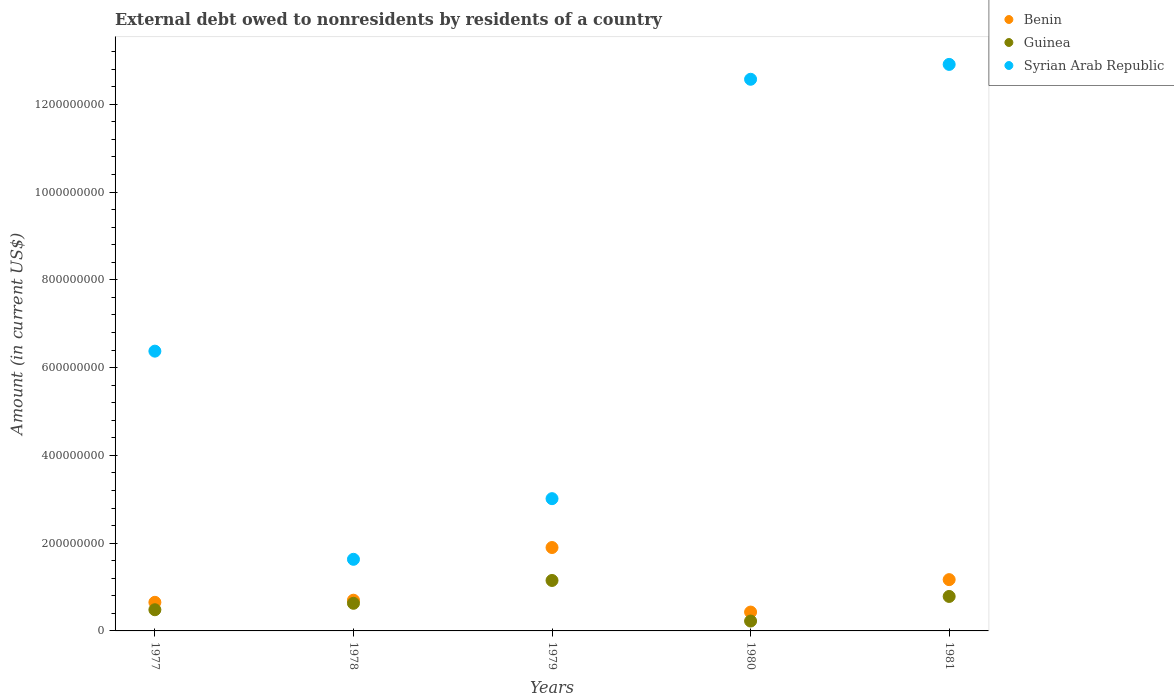How many different coloured dotlines are there?
Keep it short and to the point. 3. What is the external debt owed by residents in Benin in 1981?
Keep it short and to the point. 1.17e+08. Across all years, what is the maximum external debt owed by residents in Guinea?
Make the answer very short. 1.15e+08. Across all years, what is the minimum external debt owed by residents in Benin?
Provide a short and direct response. 4.30e+07. In which year was the external debt owed by residents in Syrian Arab Republic maximum?
Provide a short and direct response. 1981. What is the total external debt owed by residents in Guinea in the graph?
Make the answer very short. 3.27e+08. What is the difference between the external debt owed by residents in Benin in 1977 and that in 1978?
Offer a terse response. -4.82e+06. What is the difference between the external debt owed by residents in Benin in 1981 and the external debt owed by residents in Guinea in 1977?
Your response must be concise. 6.86e+07. What is the average external debt owed by residents in Benin per year?
Offer a terse response. 9.70e+07. In the year 1980, what is the difference between the external debt owed by residents in Guinea and external debt owed by residents in Syrian Arab Republic?
Your response must be concise. -1.23e+09. What is the ratio of the external debt owed by residents in Guinea in 1977 to that in 1978?
Offer a very short reply. 0.77. Is the difference between the external debt owed by residents in Guinea in 1978 and 1979 greater than the difference between the external debt owed by residents in Syrian Arab Republic in 1978 and 1979?
Offer a very short reply. Yes. What is the difference between the highest and the second highest external debt owed by residents in Guinea?
Your answer should be very brief. 3.64e+07. What is the difference between the highest and the lowest external debt owed by residents in Benin?
Provide a short and direct response. 1.47e+08. In how many years, is the external debt owed by residents in Benin greater than the average external debt owed by residents in Benin taken over all years?
Your response must be concise. 2. Does the external debt owed by residents in Syrian Arab Republic monotonically increase over the years?
Your answer should be very brief. No. Is the external debt owed by residents in Benin strictly less than the external debt owed by residents in Syrian Arab Republic over the years?
Offer a very short reply. Yes. How many dotlines are there?
Give a very brief answer. 3. How many years are there in the graph?
Give a very brief answer. 5. Does the graph contain any zero values?
Offer a terse response. No. How many legend labels are there?
Provide a short and direct response. 3. How are the legend labels stacked?
Ensure brevity in your answer.  Vertical. What is the title of the graph?
Ensure brevity in your answer.  External debt owed to nonresidents by residents of a country. What is the Amount (in current US$) of Benin in 1977?
Make the answer very short. 6.52e+07. What is the Amount (in current US$) in Guinea in 1977?
Provide a short and direct response. 4.82e+07. What is the Amount (in current US$) of Syrian Arab Republic in 1977?
Offer a very short reply. 6.37e+08. What is the Amount (in current US$) in Benin in 1978?
Your answer should be very brief. 7.00e+07. What is the Amount (in current US$) in Guinea in 1978?
Keep it short and to the point. 6.29e+07. What is the Amount (in current US$) of Syrian Arab Republic in 1978?
Ensure brevity in your answer.  1.63e+08. What is the Amount (in current US$) of Benin in 1979?
Your response must be concise. 1.90e+08. What is the Amount (in current US$) in Guinea in 1979?
Your answer should be compact. 1.15e+08. What is the Amount (in current US$) of Syrian Arab Republic in 1979?
Your answer should be very brief. 3.01e+08. What is the Amount (in current US$) of Benin in 1980?
Provide a short and direct response. 4.30e+07. What is the Amount (in current US$) in Guinea in 1980?
Offer a very short reply. 2.25e+07. What is the Amount (in current US$) in Syrian Arab Republic in 1980?
Offer a very short reply. 1.26e+09. What is the Amount (in current US$) of Benin in 1981?
Keep it short and to the point. 1.17e+08. What is the Amount (in current US$) in Guinea in 1981?
Your response must be concise. 7.85e+07. What is the Amount (in current US$) of Syrian Arab Republic in 1981?
Ensure brevity in your answer.  1.29e+09. Across all years, what is the maximum Amount (in current US$) of Benin?
Provide a succinct answer. 1.90e+08. Across all years, what is the maximum Amount (in current US$) in Guinea?
Provide a short and direct response. 1.15e+08. Across all years, what is the maximum Amount (in current US$) of Syrian Arab Republic?
Make the answer very short. 1.29e+09. Across all years, what is the minimum Amount (in current US$) in Benin?
Keep it short and to the point. 4.30e+07. Across all years, what is the minimum Amount (in current US$) in Guinea?
Give a very brief answer. 2.25e+07. Across all years, what is the minimum Amount (in current US$) in Syrian Arab Republic?
Your response must be concise. 1.63e+08. What is the total Amount (in current US$) in Benin in the graph?
Offer a terse response. 4.85e+08. What is the total Amount (in current US$) of Guinea in the graph?
Your response must be concise. 3.27e+08. What is the total Amount (in current US$) in Syrian Arab Republic in the graph?
Ensure brevity in your answer.  3.65e+09. What is the difference between the Amount (in current US$) of Benin in 1977 and that in 1978?
Give a very brief answer. -4.82e+06. What is the difference between the Amount (in current US$) in Guinea in 1977 and that in 1978?
Provide a succinct answer. -1.47e+07. What is the difference between the Amount (in current US$) in Syrian Arab Republic in 1977 and that in 1978?
Provide a short and direct response. 4.74e+08. What is the difference between the Amount (in current US$) of Benin in 1977 and that in 1979?
Your answer should be compact. -1.25e+08. What is the difference between the Amount (in current US$) in Guinea in 1977 and that in 1979?
Offer a very short reply. -6.67e+07. What is the difference between the Amount (in current US$) of Syrian Arab Republic in 1977 and that in 1979?
Offer a very short reply. 3.36e+08. What is the difference between the Amount (in current US$) of Benin in 1977 and that in 1980?
Your answer should be compact. 2.22e+07. What is the difference between the Amount (in current US$) in Guinea in 1977 and that in 1980?
Give a very brief answer. 2.58e+07. What is the difference between the Amount (in current US$) in Syrian Arab Republic in 1977 and that in 1980?
Ensure brevity in your answer.  -6.19e+08. What is the difference between the Amount (in current US$) in Benin in 1977 and that in 1981?
Your answer should be compact. -5.17e+07. What is the difference between the Amount (in current US$) in Guinea in 1977 and that in 1981?
Provide a succinct answer. -3.03e+07. What is the difference between the Amount (in current US$) in Syrian Arab Republic in 1977 and that in 1981?
Offer a terse response. -6.53e+08. What is the difference between the Amount (in current US$) in Benin in 1978 and that in 1979?
Provide a succinct answer. -1.20e+08. What is the difference between the Amount (in current US$) in Guinea in 1978 and that in 1979?
Your answer should be very brief. -5.20e+07. What is the difference between the Amount (in current US$) of Syrian Arab Republic in 1978 and that in 1979?
Your response must be concise. -1.38e+08. What is the difference between the Amount (in current US$) in Benin in 1978 and that in 1980?
Provide a short and direct response. 2.70e+07. What is the difference between the Amount (in current US$) in Guinea in 1978 and that in 1980?
Give a very brief answer. 4.05e+07. What is the difference between the Amount (in current US$) in Syrian Arab Republic in 1978 and that in 1980?
Keep it short and to the point. -1.09e+09. What is the difference between the Amount (in current US$) in Benin in 1978 and that in 1981?
Offer a very short reply. -4.69e+07. What is the difference between the Amount (in current US$) of Guinea in 1978 and that in 1981?
Your response must be concise. -1.56e+07. What is the difference between the Amount (in current US$) in Syrian Arab Republic in 1978 and that in 1981?
Your answer should be very brief. -1.13e+09. What is the difference between the Amount (in current US$) in Benin in 1979 and that in 1980?
Ensure brevity in your answer.  1.47e+08. What is the difference between the Amount (in current US$) of Guinea in 1979 and that in 1980?
Ensure brevity in your answer.  9.25e+07. What is the difference between the Amount (in current US$) of Syrian Arab Republic in 1979 and that in 1980?
Provide a short and direct response. -9.56e+08. What is the difference between the Amount (in current US$) in Benin in 1979 and that in 1981?
Provide a succinct answer. 7.32e+07. What is the difference between the Amount (in current US$) of Guinea in 1979 and that in 1981?
Offer a very short reply. 3.64e+07. What is the difference between the Amount (in current US$) in Syrian Arab Republic in 1979 and that in 1981?
Your answer should be compact. -9.89e+08. What is the difference between the Amount (in current US$) in Benin in 1980 and that in 1981?
Offer a terse response. -7.39e+07. What is the difference between the Amount (in current US$) in Guinea in 1980 and that in 1981?
Make the answer very short. -5.61e+07. What is the difference between the Amount (in current US$) of Syrian Arab Republic in 1980 and that in 1981?
Your answer should be compact. -3.39e+07. What is the difference between the Amount (in current US$) of Benin in 1977 and the Amount (in current US$) of Guinea in 1978?
Your answer should be very brief. 2.22e+06. What is the difference between the Amount (in current US$) of Benin in 1977 and the Amount (in current US$) of Syrian Arab Republic in 1978?
Your answer should be compact. -9.80e+07. What is the difference between the Amount (in current US$) of Guinea in 1977 and the Amount (in current US$) of Syrian Arab Republic in 1978?
Provide a short and direct response. -1.15e+08. What is the difference between the Amount (in current US$) in Benin in 1977 and the Amount (in current US$) in Guinea in 1979?
Your answer should be very brief. -4.98e+07. What is the difference between the Amount (in current US$) of Benin in 1977 and the Amount (in current US$) of Syrian Arab Republic in 1979?
Offer a terse response. -2.36e+08. What is the difference between the Amount (in current US$) in Guinea in 1977 and the Amount (in current US$) in Syrian Arab Republic in 1979?
Offer a very short reply. -2.53e+08. What is the difference between the Amount (in current US$) in Benin in 1977 and the Amount (in current US$) in Guinea in 1980?
Provide a short and direct response. 4.27e+07. What is the difference between the Amount (in current US$) of Benin in 1977 and the Amount (in current US$) of Syrian Arab Republic in 1980?
Provide a succinct answer. -1.19e+09. What is the difference between the Amount (in current US$) in Guinea in 1977 and the Amount (in current US$) in Syrian Arab Republic in 1980?
Give a very brief answer. -1.21e+09. What is the difference between the Amount (in current US$) of Benin in 1977 and the Amount (in current US$) of Guinea in 1981?
Give a very brief answer. -1.34e+07. What is the difference between the Amount (in current US$) of Benin in 1977 and the Amount (in current US$) of Syrian Arab Republic in 1981?
Ensure brevity in your answer.  -1.23e+09. What is the difference between the Amount (in current US$) of Guinea in 1977 and the Amount (in current US$) of Syrian Arab Republic in 1981?
Give a very brief answer. -1.24e+09. What is the difference between the Amount (in current US$) of Benin in 1978 and the Amount (in current US$) of Guinea in 1979?
Make the answer very short. -4.50e+07. What is the difference between the Amount (in current US$) of Benin in 1978 and the Amount (in current US$) of Syrian Arab Republic in 1979?
Your response must be concise. -2.31e+08. What is the difference between the Amount (in current US$) of Guinea in 1978 and the Amount (in current US$) of Syrian Arab Republic in 1979?
Offer a very short reply. -2.38e+08. What is the difference between the Amount (in current US$) in Benin in 1978 and the Amount (in current US$) in Guinea in 1980?
Your answer should be compact. 4.75e+07. What is the difference between the Amount (in current US$) in Benin in 1978 and the Amount (in current US$) in Syrian Arab Republic in 1980?
Give a very brief answer. -1.19e+09. What is the difference between the Amount (in current US$) of Guinea in 1978 and the Amount (in current US$) of Syrian Arab Republic in 1980?
Offer a terse response. -1.19e+09. What is the difference between the Amount (in current US$) in Benin in 1978 and the Amount (in current US$) in Guinea in 1981?
Offer a terse response. -8.57e+06. What is the difference between the Amount (in current US$) of Benin in 1978 and the Amount (in current US$) of Syrian Arab Republic in 1981?
Offer a terse response. -1.22e+09. What is the difference between the Amount (in current US$) in Guinea in 1978 and the Amount (in current US$) in Syrian Arab Republic in 1981?
Your response must be concise. -1.23e+09. What is the difference between the Amount (in current US$) of Benin in 1979 and the Amount (in current US$) of Guinea in 1980?
Your answer should be very brief. 1.68e+08. What is the difference between the Amount (in current US$) in Benin in 1979 and the Amount (in current US$) in Syrian Arab Republic in 1980?
Your response must be concise. -1.07e+09. What is the difference between the Amount (in current US$) of Guinea in 1979 and the Amount (in current US$) of Syrian Arab Republic in 1980?
Provide a succinct answer. -1.14e+09. What is the difference between the Amount (in current US$) in Benin in 1979 and the Amount (in current US$) in Guinea in 1981?
Make the answer very short. 1.11e+08. What is the difference between the Amount (in current US$) in Benin in 1979 and the Amount (in current US$) in Syrian Arab Republic in 1981?
Make the answer very short. -1.10e+09. What is the difference between the Amount (in current US$) of Guinea in 1979 and the Amount (in current US$) of Syrian Arab Republic in 1981?
Give a very brief answer. -1.18e+09. What is the difference between the Amount (in current US$) in Benin in 1980 and the Amount (in current US$) in Guinea in 1981?
Give a very brief answer. -3.56e+07. What is the difference between the Amount (in current US$) of Benin in 1980 and the Amount (in current US$) of Syrian Arab Republic in 1981?
Your answer should be compact. -1.25e+09. What is the difference between the Amount (in current US$) in Guinea in 1980 and the Amount (in current US$) in Syrian Arab Republic in 1981?
Offer a terse response. -1.27e+09. What is the average Amount (in current US$) of Benin per year?
Ensure brevity in your answer.  9.70e+07. What is the average Amount (in current US$) in Guinea per year?
Provide a short and direct response. 6.54e+07. What is the average Amount (in current US$) in Syrian Arab Republic per year?
Your answer should be compact. 7.30e+08. In the year 1977, what is the difference between the Amount (in current US$) in Benin and Amount (in current US$) in Guinea?
Provide a short and direct response. 1.69e+07. In the year 1977, what is the difference between the Amount (in current US$) in Benin and Amount (in current US$) in Syrian Arab Republic?
Offer a terse response. -5.72e+08. In the year 1977, what is the difference between the Amount (in current US$) in Guinea and Amount (in current US$) in Syrian Arab Republic?
Provide a short and direct response. -5.89e+08. In the year 1978, what is the difference between the Amount (in current US$) of Benin and Amount (in current US$) of Guinea?
Your answer should be compact. 7.03e+06. In the year 1978, what is the difference between the Amount (in current US$) of Benin and Amount (in current US$) of Syrian Arab Republic?
Provide a succinct answer. -9.32e+07. In the year 1978, what is the difference between the Amount (in current US$) of Guinea and Amount (in current US$) of Syrian Arab Republic?
Keep it short and to the point. -1.00e+08. In the year 1979, what is the difference between the Amount (in current US$) in Benin and Amount (in current US$) in Guinea?
Give a very brief answer. 7.51e+07. In the year 1979, what is the difference between the Amount (in current US$) of Benin and Amount (in current US$) of Syrian Arab Republic?
Offer a terse response. -1.11e+08. In the year 1979, what is the difference between the Amount (in current US$) in Guinea and Amount (in current US$) in Syrian Arab Republic?
Make the answer very short. -1.86e+08. In the year 1980, what is the difference between the Amount (in current US$) in Benin and Amount (in current US$) in Guinea?
Keep it short and to the point. 2.05e+07. In the year 1980, what is the difference between the Amount (in current US$) of Benin and Amount (in current US$) of Syrian Arab Republic?
Provide a short and direct response. -1.21e+09. In the year 1980, what is the difference between the Amount (in current US$) in Guinea and Amount (in current US$) in Syrian Arab Republic?
Ensure brevity in your answer.  -1.23e+09. In the year 1981, what is the difference between the Amount (in current US$) of Benin and Amount (in current US$) of Guinea?
Ensure brevity in your answer.  3.83e+07. In the year 1981, what is the difference between the Amount (in current US$) of Benin and Amount (in current US$) of Syrian Arab Republic?
Offer a very short reply. -1.17e+09. In the year 1981, what is the difference between the Amount (in current US$) in Guinea and Amount (in current US$) in Syrian Arab Republic?
Make the answer very short. -1.21e+09. What is the ratio of the Amount (in current US$) of Benin in 1977 to that in 1978?
Keep it short and to the point. 0.93. What is the ratio of the Amount (in current US$) in Guinea in 1977 to that in 1978?
Provide a short and direct response. 0.77. What is the ratio of the Amount (in current US$) of Syrian Arab Republic in 1977 to that in 1978?
Offer a very short reply. 3.91. What is the ratio of the Amount (in current US$) of Benin in 1977 to that in 1979?
Give a very brief answer. 0.34. What is the ratio of the Amount (in current US$) of Guinea in 1977 to that in 1979?
Offer a very short reply. 0.42. What is the ratio of the Amount (in current US$) in Syrian Arab Republic in 1977 to that in 1979?
Keep it short and to the point. 2.12. What is the ratio of the Amount (in current US$) of Benin in 1977 to that in 1980?
Provide a succinct answer. 1.52. What is the ratio of the Amount (in current US$) in Guinea in 1977 to that in 1980?
Your response must be concise. 2.15. What is the ratio of the Amount (in current US$) of Syrian Arab Republic in 1977 to that in 1980?
Your answer should be compact. 0.51. What is the ratio of the Amount (in current US$) of Benin in 1977 to that in 1981?
Provide a short and direct response. 0.56. What is the ratio of the Amount (in current US$) in Guinea in 1977 to that in 1981?
Make the answer very short. 0.61. What is the ratio of the Amount (in current US$) in Syrian Arab Republic in 1977 to that in 1981?
Your answer should be compact. 0.49. What is the ratio of the Amount (in current US$) of Benin in 1978 to that in 1979?
Provide a succinct answer. 0.37. What is the ratio of the Amount (in current US$) of Guinea in 1978 to that in 1979?
Ensure brevity in your answer.  0.55. What is the ratio of the Amount (in current US$) of Syrian Arab Republic in 1978 to that in 1979?
Offer a very short reply. 0.54. What is the ratio of the Amount (in current US$) in Benin in 1978 to that in 1980?
Ensure brevity in your answer.  1.63. What is the ratio of the Amount (in current US$) in Guinea in 1978 to that in 1980?
Provide a succinct answer. 2.8. What is the ratio of the Amount (in current US$) of Syrian Arab Republic in 1978 to that in 1980?
Your response must be concise. 0.13. What is the ratio of the Amount (in current US$) in Benin in 1978 to that in 1981?
Your answer should be very brief. 0.6. What is the ratio of the Amount (in current US$) in Guinea in 1978 to that in 1981?
Ensure brevity in your answer.  0.8. What is the ratio of the Amount (in current US$) in Syrian Arab Republic in 1978 to that in 1981?
Your response must be concise. 0.13. What is the ratio of the Amount (in current US$) in Benin in 1979 to that in 1980?
Your answer should be very brief. 4.42. What is the ratio of the Amount (in current US$) of Guinea in 1979 to that in 1980?
Ensure brevity in your answer.  5.12. What is the ratio of the Amount (in current US$) in Syrian Arab Republic in 1979 to that in 1980?
Ensure brevity in your answer.  0.24. What is the ratio of the Amount (in current US$) of Benin in 1979 to that in 1981?
Make the answer very short. 1.63. What is the ratio of the Amount (in current US$) in Guinea in 1979 to that in 1981?
Keep it short and to the point. 1.46. What is the ratio of the Amount (in current US$) in Syrian Arab Republic in 1979 to that in 1981?
Ensure brevity in your answer.  0.23. What is the ratio of the Amount (in current US$) of Benin in 1980 to that in 1981?
Give a very brief answer. 0.37. What is the ratio of the Amount (in current US$) in Guinea in 1980 to that in 1981?
Provide a short and direct response. 0.29. What is the ratio of the Amount (in current US$) of Syrian Arab Republic in 1980 to that in 1981?
Ensure brevity in your answer.  0.97. What is the difference between the highest and the second highest Amount (in current US$) in Benin?
Your answer should be compact. 7.32e+07. What is the difference between the highest and the second highest Amount (in current US$) in Guinea?
Keep it short and to the point. 3.64e+07. What is the difference between the highest and the second highest Amount (in current US$) in Syrian Arab Republic?
Your answer should be compact. 3.39e+07. What is the difference between the highest and the lowest Amount (in current US$) in Benin?
Provide a short and direct response. 1.47e+08. What is the difference between the highest and the lowest Amount (in current US$) in Guinea?
Give a very brief answer. 9.25e+07. What is the difference between the highest and the lowest Amount (in current US$) of Syrian Arab Republic?
Your response must be concise. 1.13e+09. 